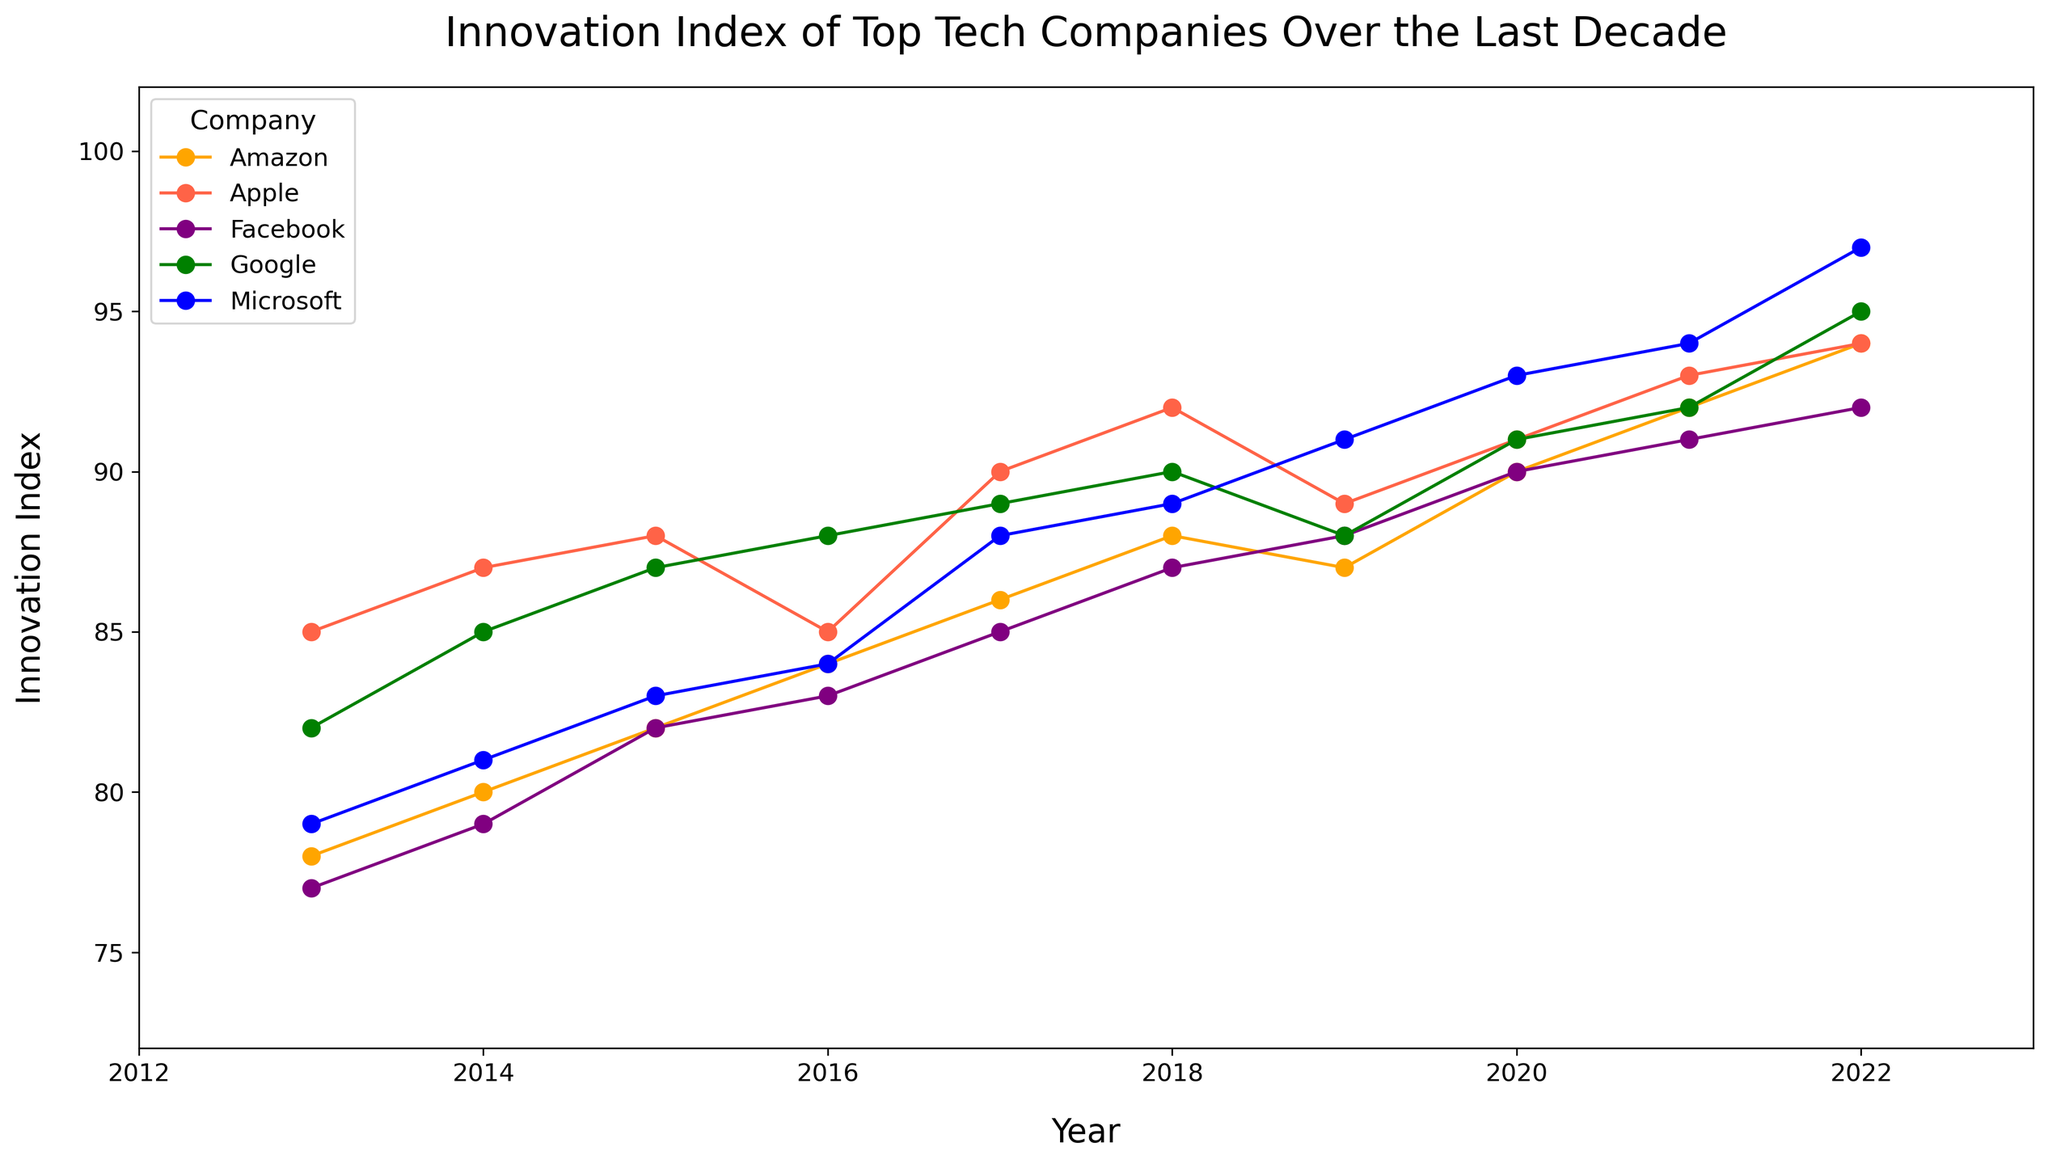What is the company with the highest Innovation Index in 2022? To answer this question, look at the data points for 2022 and identify the highest value. Microsoft has an Innovation Index of 97, which is the highest.
Answer: Microsoft Which company shows the most consistent increase in their Innovation Index over the decade? To find this, review each company's trends. Microsoft consistently increases almost every year, without any dips.
Answer: Microsoft How does Apple's Innovation Index in 2017 compare to Google's in the same year? Look at the data points for both companies in 2017. Apple's Innovation Index is 90, and Google's is 89.
Answer: Apple's is higher by 1 point What is the average Innovation Index for Facebook from 2013 to 2022? First, sum up Facebook's Innovation Index values from 2013 to 2022 (77+79+82+83+85+87+88+90+91+92 = 854). There are 10 years, so divide 854 by 10.
Answer: 85.4 What is the difference between Amazon's Innovation Index in 2022 and 2013? Subtract the 2013 value from the 2022 value for Amazon. In 2022, it is 94, and in 2013, it is 78.
Answer: 16 Which two companies had the same Innovation Index in any given year? By scanning the data, it can be seen that Amazon and Facebook both have an Innovation Index of 90 in 2020.
Answer: Amazon and Facebook Was there any year when Microsoft's Innovation Index was lower than Apple's? Review the data year by year. From 2013 to 2016, Microsoft's Innovation Index was lower than Apple's.
Answer: Yes, from 2013 to 2016 Which company had the greatest single year increase in Innovation Index, and by how much? Calculate the year-on-year differences for all companies. Microsoft had an increase from 94 in 2021 to 97 in 2022, a difference of 3, which is the highest.
Answer: Microsoft, by 3 points What is the trend of Google's Innovation Index from 2019 to 2022? Examine the data points for these years. Google's Innovation Index goes from 88 (2019) to 91 (2020), 92 (2021), and 95 (2022).
Answer: Increasing trend Compare the Innovation Index of Apple and Microsoft in 2020. By how much does the leading company exceed the other? Look at the indexes for 2020. Apple has an index of 91 and Microsoft has 93. Microsoft exceeds Apple by 2 points.
Answer: Microsoft exceeds by 2 points 